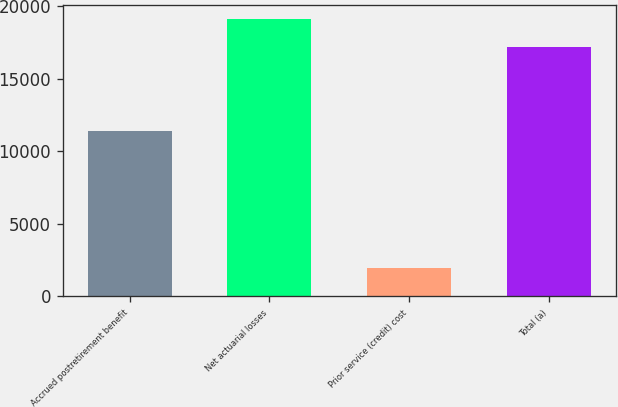Convert chart. <chart><loc_0><loc_0><loc_500><loc_500><bar_chart><fcel>Accrued postretirement benefit<fcel>Net actuarial losses<fcel>Prior service (credit) cost<fcel>Total (a)<nl><fcel>11410<fcel>19117<fcel>1931<fcel>17186<nl></chart> 